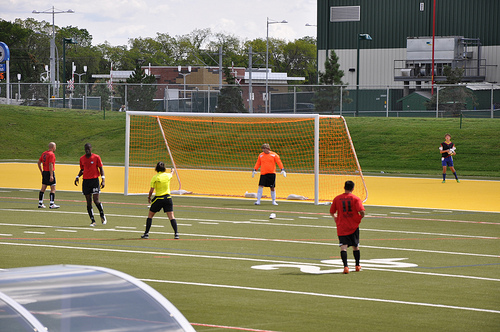<image>
Is the net behind the goalkeeper? Yes. From this viewpoint, the net is positioned behind the goalkeeper, with the goalkeeper partially or fully occluding the net. Is the man next to the man? No. The man is not positioned next to the man. They are located in different areas of the scene. Is the goalie in front of the referee? Yes. The goalie is positioned in front of the referee, appearing closer to the camera viewpoint. 